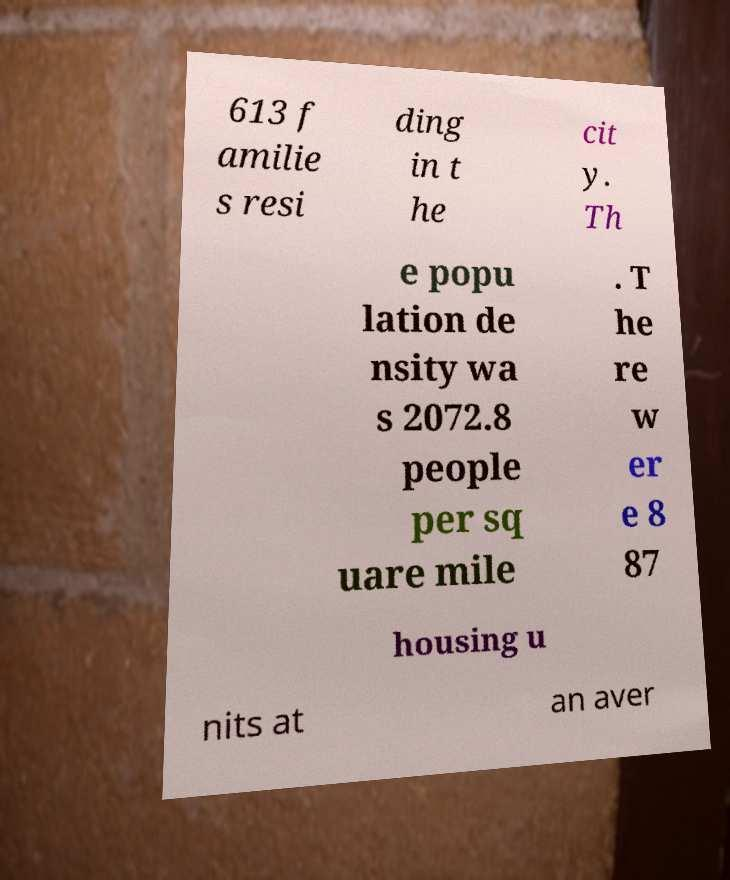Could you extract and type out the text from this image? 613 f amilie s resi ding in t he cit y. Th e popu lation de nsity wa s 2072.8 people per sq uare mile . T he re w er e 8 87 housing u nits at an aver 